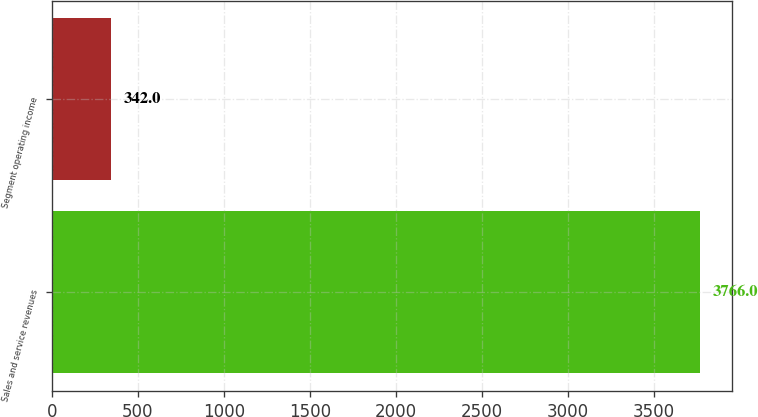Convert chart. <chart><loc_0><loc_0><loc_500><loc_500><bar_chart><fcel>Sales and service revenues<fcel>Segment operating income<nl><fcel>3766<fcel>342<nl></chart> 